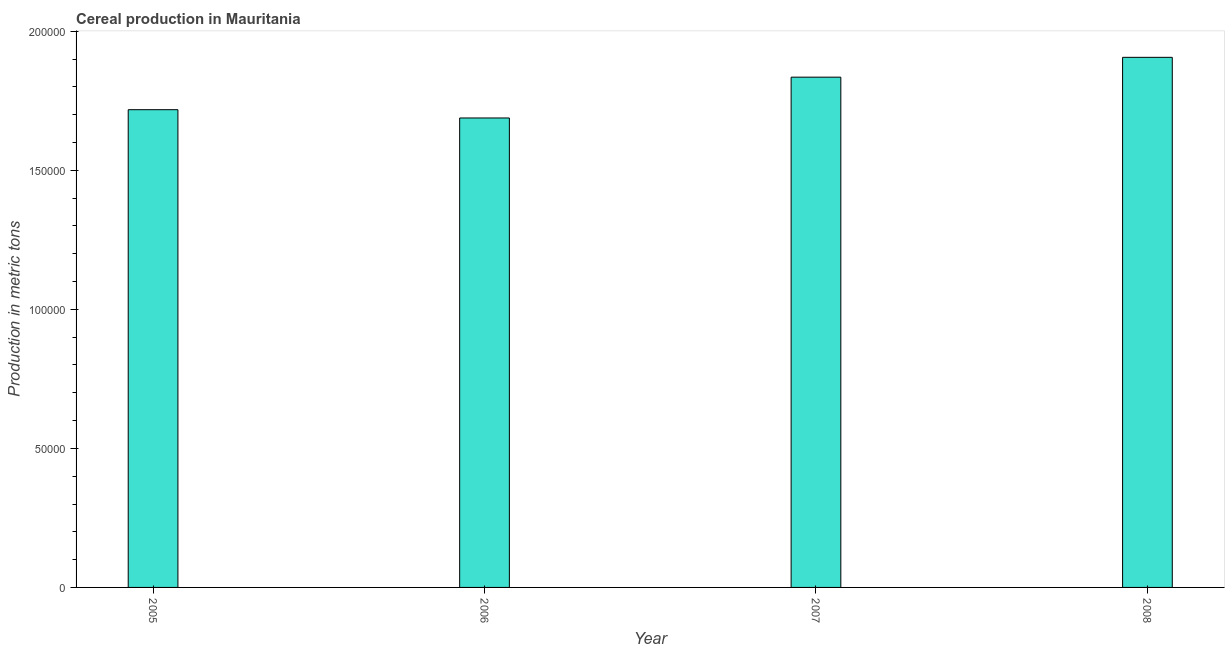Does the graph contain grids?
Give a very brief answer. No. What is the title of the graph?
Make the answer very short. Cereal production in Mauritania. What is the label or title of the X-axis?
Give a very brief answer. Year. What is the label or title of the Y-axis?
Provide a succinct answer. Production in metric tons. What is the cereal production in 2007?
Your response must be concise. 1.83e+05. Across all years, what is the maximum cereal production?
Offer a very short reply. 1.91e+05. Across all years, what is the minimum cereal production?
Provide a short and direct response. 1.69e+05. What is the sum of the cereal production?
Ensure brevity in your answer.  7.15e+05. What is the difference between the cereal production in 2007 and 2008?
Your answer should be compact. -7131. What is the average cereal production per year?
Your answer should be compact. 1.79e+05. What is the median cereal production?
Your answer should be very brief. 1.78e+05. In how many years, is the cereal production greater than 70000 metric tons?
Your response must be concise. 4. What is the ratio of the cereal production in 2006 to that in 2008?
Keep it short and to the point. 0.89. Is the cereal production in 2005 less than that in 2008?
Offer a terse response. Yes. Is the difference between the cereal production in 2005 and 2006 greater than the difference between any two years?
Offer a very short reply. No. What is the difference between the highest and the second highest cereal production?
Provide a short and direct response. 7131. What is the difference between the highest and the lowest cereal production?
Your answer should be very brief. 2.18e+04. In how many years, is the cereal production greater than the average cereal production taken over all years?
Give a very brief answer. 2. How many years are there in the graph?
Provide a short and direct response. 4. Are the values on the major ticks of Y-axis written in scientific E-notation?
Offer a terse response. No. What is the Production in metric tons in 2005?
Ensure brevity in your answer.  1.72e+05. What is the Production in metric tons in 2006?
Ensure brevity in your answer.  1.69e+05. What is the Production in metric tons in 2007?
Ensure brevity in your answer.  1.83e+05. What is the Production in metric tons of 2008?
Your answer should be compact. 1.91e+05. What is the difference between the Production in metric tons in 2005 and 2006?
Ensure brevity in your answer.  2976. What is the difference between the Production in metric tons in 2005 and 2007?
Make the answer very short. -1.17e+04. What is the difference between the Production in metric tons in 2005 and 2008?
Offer a terse response. -1.88e+04. What is the difference between the Production in metric tons in 2006 and 2007?
Make the answer very short. -1.47e+04. What is the difference between the Production in metric tons in 2006 and 2008?
Give a very brief answer. -2.18e+04. What is the difference between the Production in metric tons in 2007 and 2008?
Provide a succinct answer. -7131. What is the ratio of the Production in metric tons in 2005 to that in 2006?
Offer a very short reply. 1.02. What is the ratio of the Production in metric tons in 2005 to that in 2007?
Offer a terse response. 0.94. What is the ratio of the Production in metric tons in 2005 to that in 2008?
Provide a short and direct response. 0.9. What is the ratio of the Production in metric tons in 2006 to that in 2008?
Ensure brevity in your answer.  0.89. What is the ratio of the Production in metric tons in 2007 to that in 2008?
Ensure brevity in your answer.  0.96. 